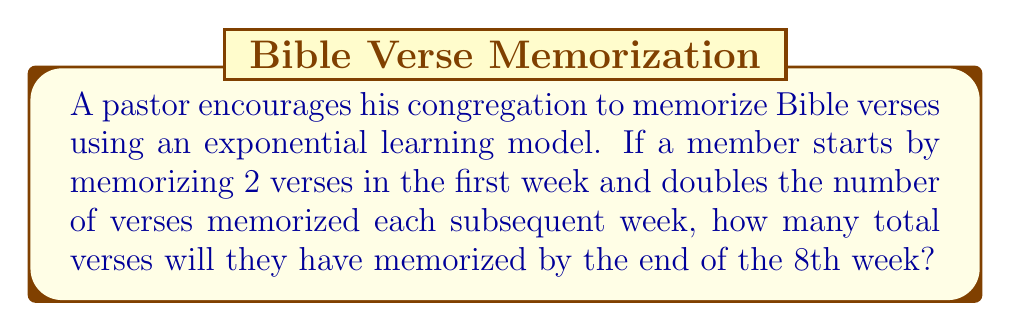Solve this math problem. Let's approach this step-by-step using the exponential growth formula:

1) The number of verses memorized each week follows the pattern:
   Week 1: $2$ verses
   Week 2: $2 \times 2 = 2^2$ verses
   Week 3: $2 \times 2 \times 2 = 2^3$ verses
   ...and so on.

2) For week $n$, the number of verses memorized is $2^n$.

3) To find the total number of verses memorized by the end of the 8th week, we need to sum the verses from week 1 to week 8:

   $S = 2^1 + 2^2 + 2^3 + 2^4 + 2^5 + 2^6 + 2^7 + 2^8$

4) This is a geometric series with first term $a=2$ and common ratio $r=2$.

5) The sum of a geometric series is given by the formula:
   $$S = \frac{a(1-r^n)}{1-r}$$
   where $a$ is the first term, $r$ is the common ratio, and $n$ is the number of terms.

6) Substituting our values:
   $$S = \frac{2(1-2^8)}{1-2} = \frac{2(1-256)}{-1} = 2(255) = 510$$

Thus, by the end of the 8th week, the congregation member will have memorized 510 verses in total.
Answer: 510 verses 